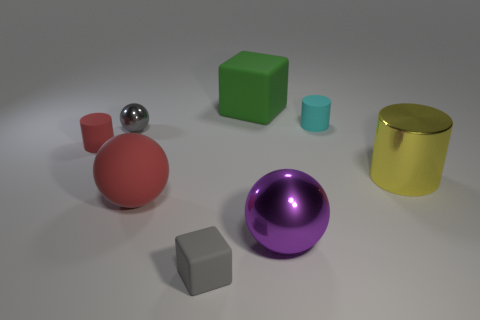Could you describe the lighting in the scene? The scene is softly lit from above, leading to gentle shadows under the objects, indicating a diffused light source, possibly out of view. Does the lighting affect the colors of the objects? Yes, the diffused lighting enhances the objects' colors by providing even illumination without harsh glares or overly dark shadows, preserving the richness of their hues. 